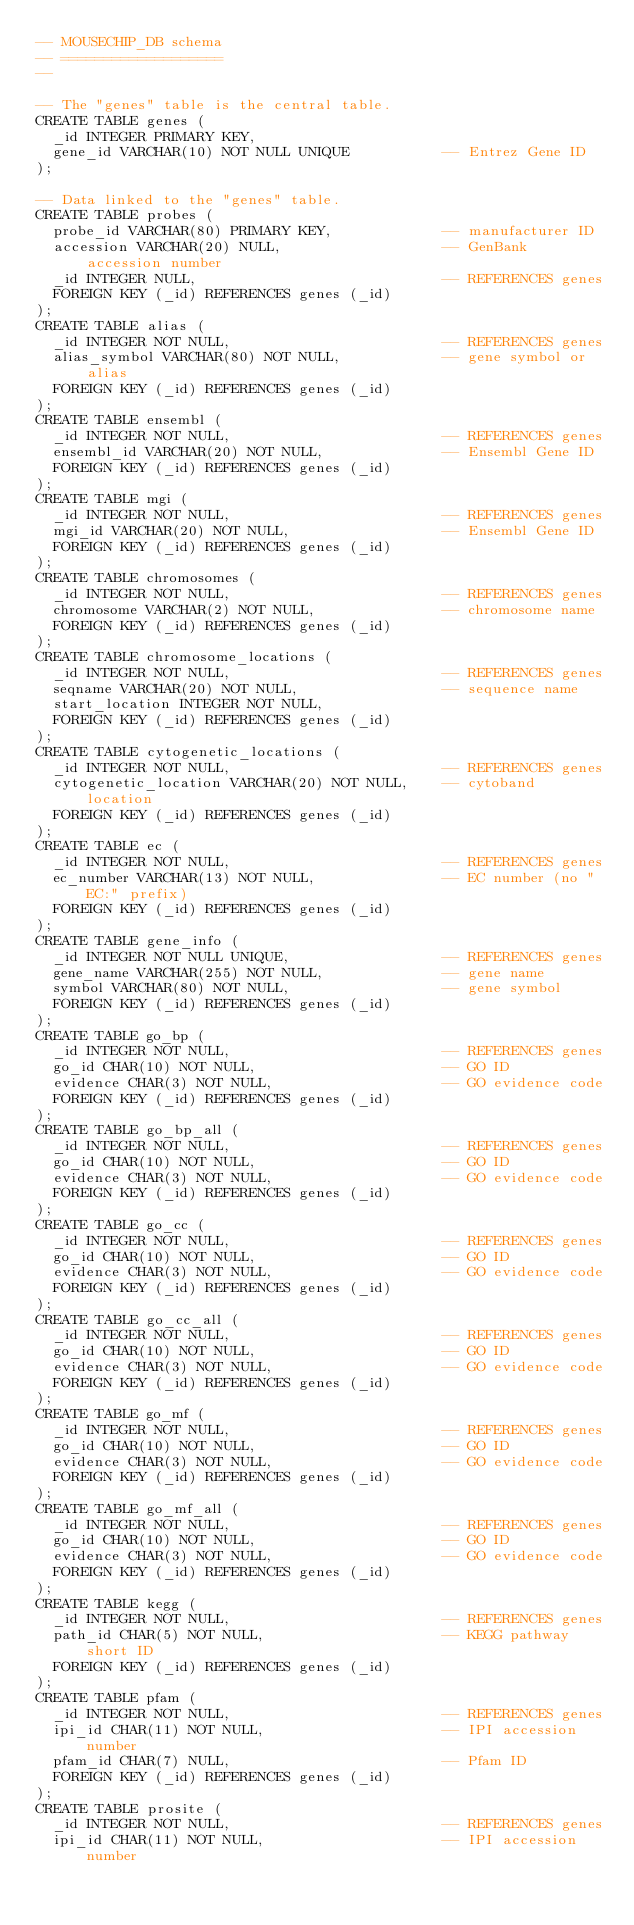Convert code to text. <code><loc_0><loc_0><loc_500><loc_500><_SQL_>-- MOUSECHIP_DB schema
-- ===================
--

-- The "genes" table is the central table.
CREATE TABLE genes (
  _id INTEGER PRIMARY KEY,
  gene_id VARCHAR(10) NOT NULL UNIQUE           -- Entrez Gene ID
);

-- Data linked to the "genes" table.
CREATE TABLE probes (
  probe_id VARCHAR(80) PRIMARY KEY,             -- manufacturer ID
  accession VARCHAR(20) NULL,                   -- GenBank accession number
  _id INTEGER NULL,                             -- REFERENCES genes
  FOREIGN KEY (_id) REFERENCES genes (_id)
);
CREATE TABLE alias (
  _id INTEGER NOT NULL,                         -- REFERENCES genes
  alias_symbol VARCHAR(80) NOT NULL,            -- gene symbol or alias
  FOREIGN KEY (_id) REFERENCES genes (_id)
);
CREATE TABLE ensembl (
  _id INTEGER NOT NULL,                         -- REFERENCES genes
  ensembl_id VARCHAR(20) NOT NULL,              -- Ensembl Gene ID
  FOREIGN KEY (_id) REFERENCES genes (_id)
);
CREATE TABLE mgi (
  _id INTEGER NOT NULL,                         -- REFERENCES genes
  mgi_id VARCHAR(20) NOT NULL,                  -- Ensembl Gene ID
  FOREIGN KEY (_id) REFERENCES genes (_id)
);
CREATE TABLE chromosomes (
  _id INTEGER NOT NULL,                         -- REFERENCES genes
  chromosome VARCHAR(2) NOT NULL,               -- chromosome name
  FOREIGN KEY (_id) REFERENCES genes (_id)
);
CREATE TABLE chromosome_locations (
  _id INTEGER NOT NULL,                         -- REFERENCES genes
  seqname VARCHAR(20) NOT NULL,                 -- sequence name
  start_location INTEGER NOT NULL,
  FOREIGN KEY (_id) REFERENCES genes (_id)
);
CREATE TABLE cytogenetic_locations (
  _id INTEGER NOT NULL,                         -- REFERENCES genes
  cytogenetic_location VARCHAR(20) NOT NULL,    -- cytoband location
  FOREIGN KEY (_id) REFERENCES genes (_id)
);
CREATE TABLE ec (
  _id INTEGER NOT NULL,                         -- REFERENCES genes
  ec_number VARCHAR(13) NOT NULL,               -- EC number (no "EC:" prefix)
  FOREIGN KEY (_id) REFERENCES genes (_id)
);
CREATE TABLE gene_info (
  _id INTEGER NOT NULL UNIQUE,                  -- REFERENCES genes
  gene_name VARCHAR(255) NOT NULL,              -- gene name
  symbol VARCHAR(80) NOT NULL,                  -- gene symbol
  FOREIGN KEY (_id) REFERENCES genes (_id)
);
CREATE TABLE go_bp (
  _id INTEGER NOT NULL,                         -- REFERENCES genes
  go_id CHAR(10) NOT NULL,                      -- GO ID
  evidence CHAR(3) NOT NULL,                    -- GO evidence code
  FOREIGN KEY (_id) REFERENCES genes (_id)
);
CREATE TABLE go_bp_all (
  _id INTEGER NOT NULL,                         -- REFERENCES genes
  go_id CHAR(10) NOT NULL,                      -- GO ID
  evidence CHAR(3) NOT NULL,                    -- GO evidence code
  FOREIGN KEY (_id) REFERENCES genes (_id)
);
CREATE TABLE go_cc (
  _id INTEGER NOT NULL,                         -- REFERENCES genes
  go_id CHAR(10) NOT NULL,                      -- GO ID
  evidence CHAR(3) NOT NULL,                    -- GO evidence code
  FOREIGN KEY (_id) REFERENCES genes (_id)
);
CREATE TABLE go_cc_all (
  _id INTEGER NOT NULL,                         -- REFERENCES genes
  go_id CHAR(10) NOT NULL,                      -- GO ID
  evidence CHAR(3) NOT NULL,                    -- GO evidence code
  FOREIGN KEY (_id) REFERENCES genes (_id)
);
CREATE TABLE go_mf (
  _id INTEGER NOT NULL,                         -- REFERENCES genes
  go_id CHAR(10) NOT NULL,                      -- GO ID
  evidence CHAR(3) NOT NULL,                    -- GO evidence code
  FOREIGN KEY (_id) REFERENCES genes (_id)
);
CREATE TABLE go_mf_all (
  _id INTEGER NOT NULL,                         -- REFERENCES genes
  go_id CHAR(10) NOT NULL,                      -- GO ID
  evidence CHAR(3) NOT NULL,                    -- GO evidence code
  FOREIGN KEY (_id) REFERENCES genes (_id)
);
CREATE TABLE kegg (
  _id INTEGER NOT NULL,                         -- REFERENCES genes
  path_id CHAR(5) NOT NULL,                     -- KEGG pathway short ID
  FOREIGN KEY (_id) REFERENCES genes (_id)
);
CREATE TABLE pfam (
  _id INTEGER NOT NULL,                         -- REFERENCES genes
  ipi_id CHAR(11) NOT NULL,                     -- IPI accession number
  pfam_id CHAR(7) NULL,                         -- Pfam ID
  FOREIGN KEY (_id) REFERENCES genes (_id)
);
CREATE TABLE prosite (
  _id INTEGER NOT NULL,                         -- REFERENCES genes
  ipi_id CHAR(11) NOT NULL,                     -- IPI accession number</code> 